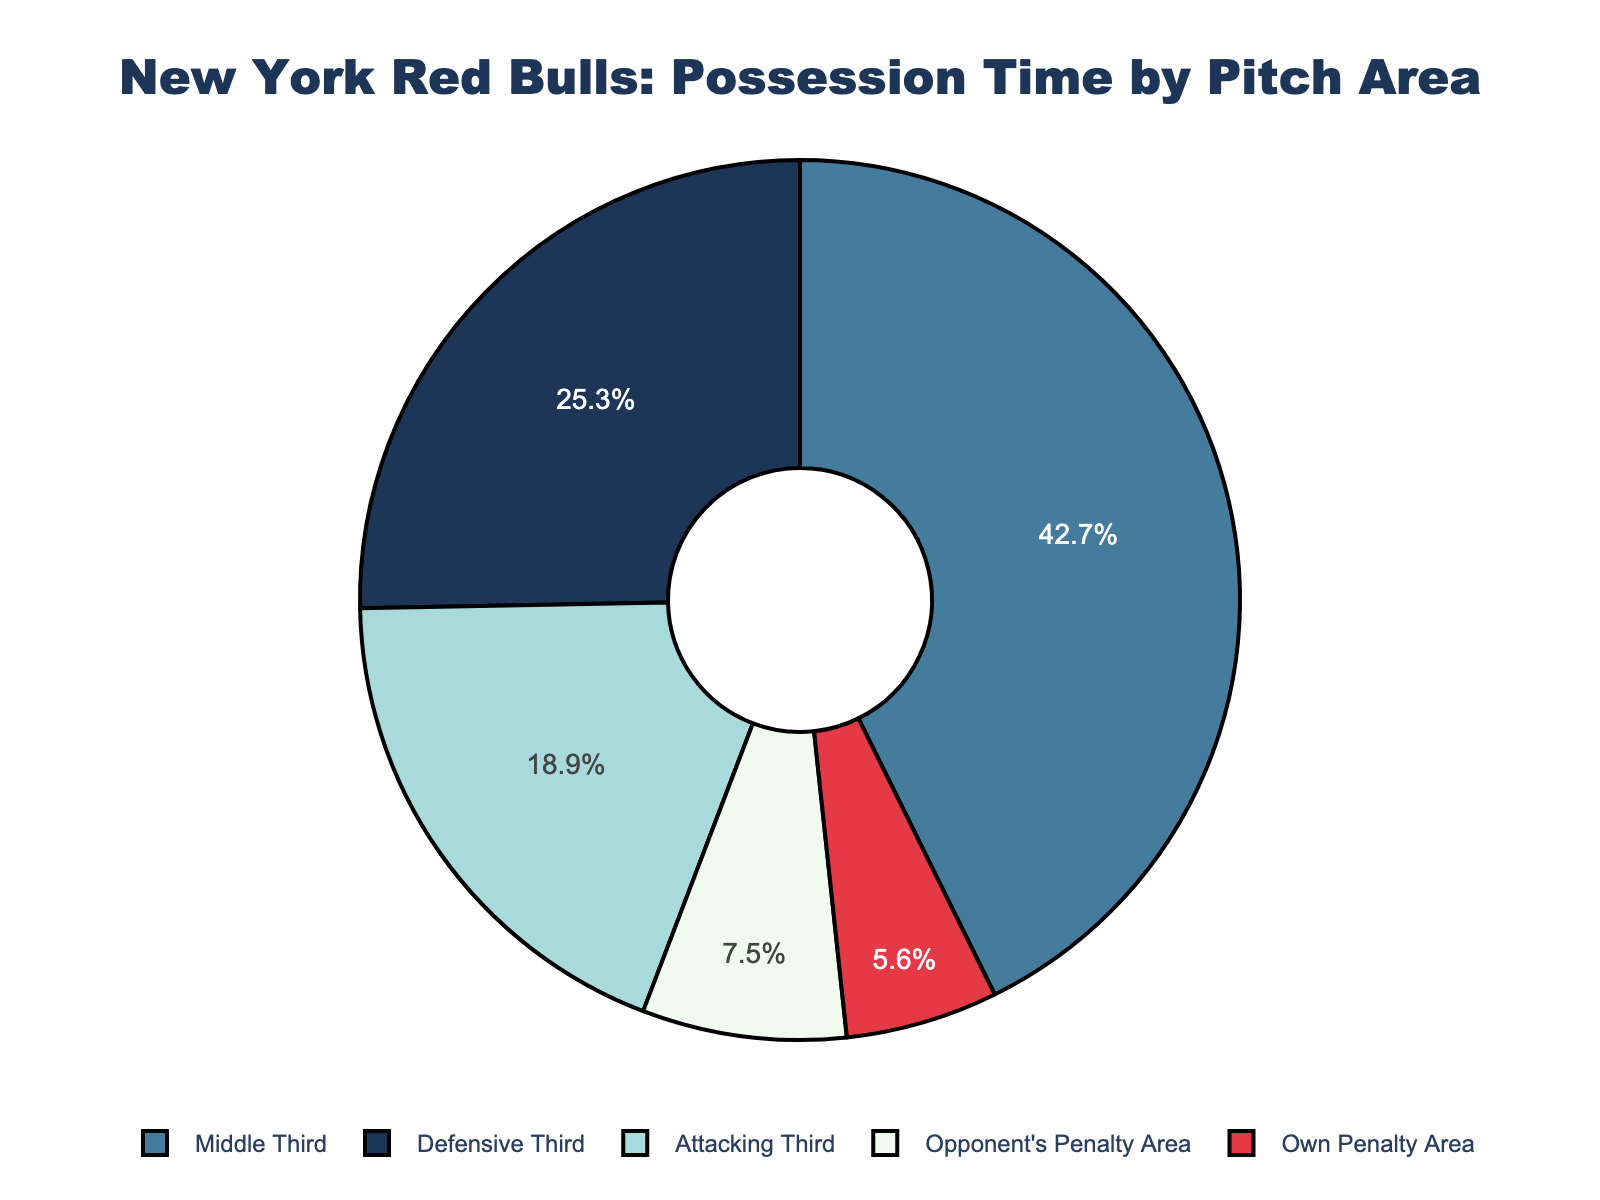What's the area with the highest possession time percentage? The Middle Third has the highest possession time percentage at 42.7%. This can be seen from the figure where the segment representing the Middle Third is the largest portion of the pie chart.
Answer: Middle Third How much time does the New York Red Bulls spend in the Defensive Third compared to the Attacking Third? The possession time in the Defensive Third is 25.3%, while in the Attacking Third it is 18.9%. Comparing these, the Defensive Third has a higher possession time.
Answer: Defensive Third What is the sum of the possession time percentages for the Defensive Third and Opponent's Penalty Area? The possession time percentage for the Defensive Third is 25.3%, and for the Opponent's Penalty Area is 7.5%. Summing these: 25.3% + 7.5% = 32.8%.
Answer: 32.8% Which area has the least possession time, and how does it compare to the area with the highest possession time? The area with the least possession time is the Own Penalty Area at 5.6%. Comparing it to the Middle Third, which has the highest possession time at 42.7%, the Own Penalty Area has significantly less possession time.
Answer: Own Penalty Area; significantly less What is the difference in possession time percentage between the Middle Third and the Attacking Third? The possession time percentage in the Middle Third is 42.7%, and in the Attacking Third it is 18.9%. The difference is: 42.7% - 18.9% = 23.8%.
Answer: 23.8% Which colors correspond to the Offensive and Defensive areas of the pitch? The Attacking Third (offensive area) is represented by a lighter blue, and the Defensive Third is represented by a dark blue. The Opponent's Penalty Area, another offensive area, is red, and the Own Penalty Area is represented by light blue.
Answer: Light blue, red (offensive); dark blue, light blue (defensive) What are the combined possession times in the Attacking Third and Opponent's Penalty Area? The possession time in the Attacking Third is 18.9%, and the Opponent's Penalty Area has 7.5%. Combined possession time is: 18.9% + 7.5% = 26.4%.
Answer: 26.4% What portion of the possession time does the New York Red Bulls have outside the Middle Third? To find the portion outside the Middle Third, subtract the Middle Third percentage from 100%: 100% - 42.7% = 57.3%.
Answer: 57.3% 